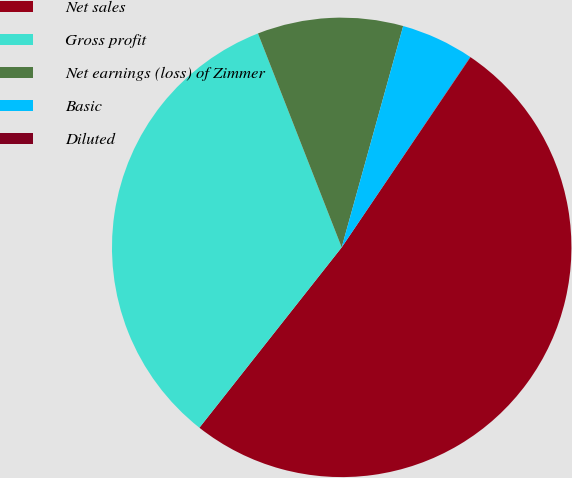<chart> <loc_0><loc_0><loc_500><loc_500><pie_chart><fcel>Net sales<fcel>Gross profit<fcel>Net earnings (loss) of Zimmer<fcel>Basic<fcel>Diluted<nl><fcel>51.16%<fcel>33.43%<fcel>10.25%<fcel>5.14%<fcel>0.02%<nl></chart> 